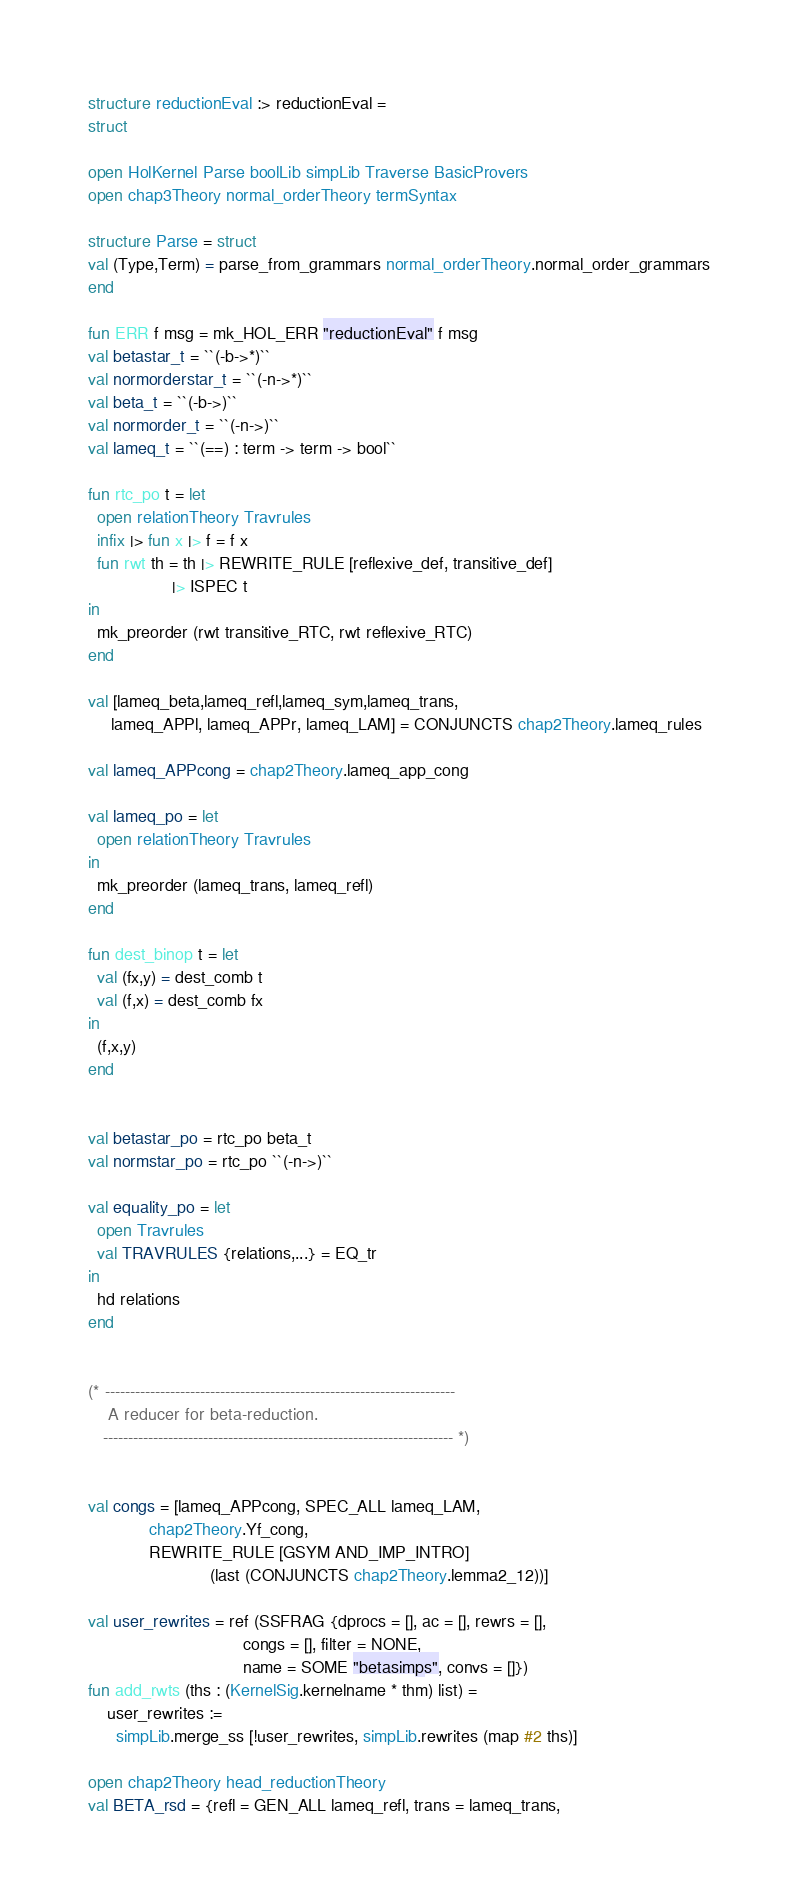Convert code to text. <code><loc_0><loc_0><loc_500><loc_500><_SML_>structure reductionEval :> reductionEval =
struct

open HolKernel Parse boolLib simpLib Traverse BasicProvers
open chap3Theory normal_orderTheory termSyntax

structure Parse = struct
val (Type,Term) = parse_from_grammars normal_orderTheory.normal_order_grammars
end

fun ERR f msg = mk_HOL_ERR "reductionEval" f msg
val betastar_t = ``(-b->*)``
val normorderstar_t = ``(-n->*)``
val beta_t = ``(-b->)``
val normorder_t = ``(-n->)``
val lameq_t = ``(==) : term -> term -> bool``

fun rtc_po t = let
  open relationTheory Travrules
  infix |> fun x |> f = f x
  fun rwt th = th |> REWRITE_RULE [reflexive_def, transitive_def]
                  |> ISPEC t
in
  mk_preorder (rwt transitive_RTC, rwt reflexive_RTC)
end

val [lameq_beta,lameq_refl,lameq_sym,lameq_trans,
     lameq_APPl, lameq_APPr, lameq_LAM] = CONJUNCTS chap2Theory.lameq_rules

val lameq_APPcong = chap2Theory.lameq_app_cong

val lameq_po = let
  open relationTheory Travrules
in
  mk_preorder (lameq_trans, lameq_refl)
end

fun dest_binop t = let
  val (fx,y) = dest_comb t
  val (f,x) = dest_comb fx
in
  (f,x,y)
end


val betastar_po = rtc_po beta_t
val normstar_po = rtc_po ``(-n->)``

val equality_po = let
  open Travrules
  val TRAVRULES {relations,...} = EQ_tr
in
  hd relations
end


(* ----------------------------------------------------------------------
    A reducer for beta-reduction.
   ---------------------------------------------------------------------- *)


val congs = [lameq_APPcong, SPEC_ALL lameq_LAM,
             chap2Theory.Yf_cong,
             REWRITE_RULE [GSYM AND_IMP_INTRO]
                          (last (CONJUNCTS chap2Theory.lemma2_12))]

val user_rewrites = ref (SSFRAG {dprocs = [], ac = [], rewrs = [],
                                 congs = [], filter = NONE,
                                 name = SOME "betasimps", convs = []})
fun add_rwts (ths : (KernelSig.kernelname * thm) list) =
    user_rewrites :=
      simpLib.merge_ss [!user_rewrites, simpLib.rewrites (map #2 ths)]

open chap2Theory head_reductionTheory
val BETA_rsd = {refl = GEN_ALL lameq_refl, trans = lameq_trans,</code> 